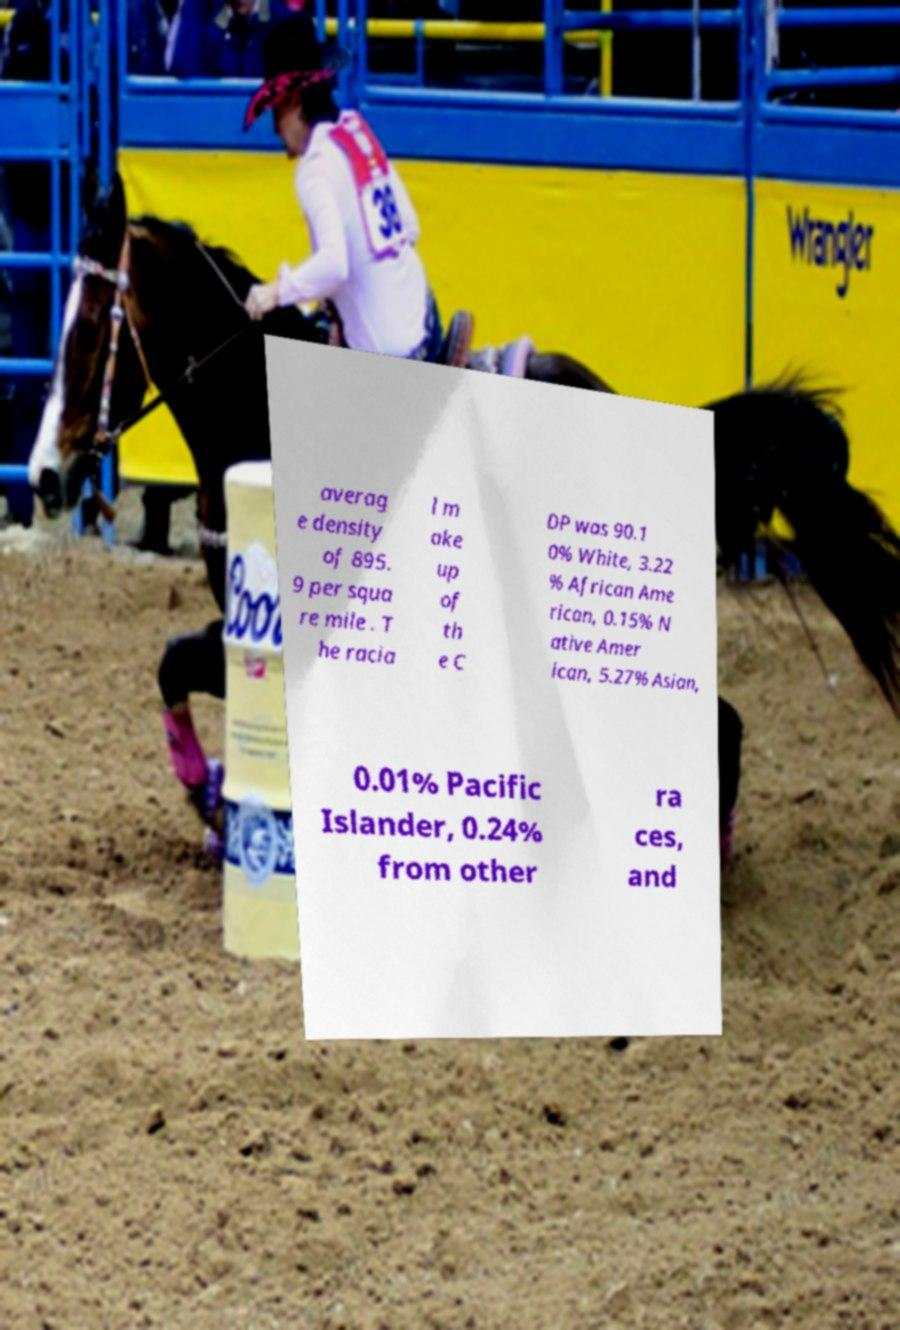Please identify and transcribe the text found in this image. averag e density of 895. 9 per squa re mile . T he racia l m ake up of th e C DP was 90.1 0% White, 3.22 % African Ame rican, 0.15% N ative Amer ican, 5.27% Asian, 0.01% Pacific Islander, 0.24% from other ra ces, and 